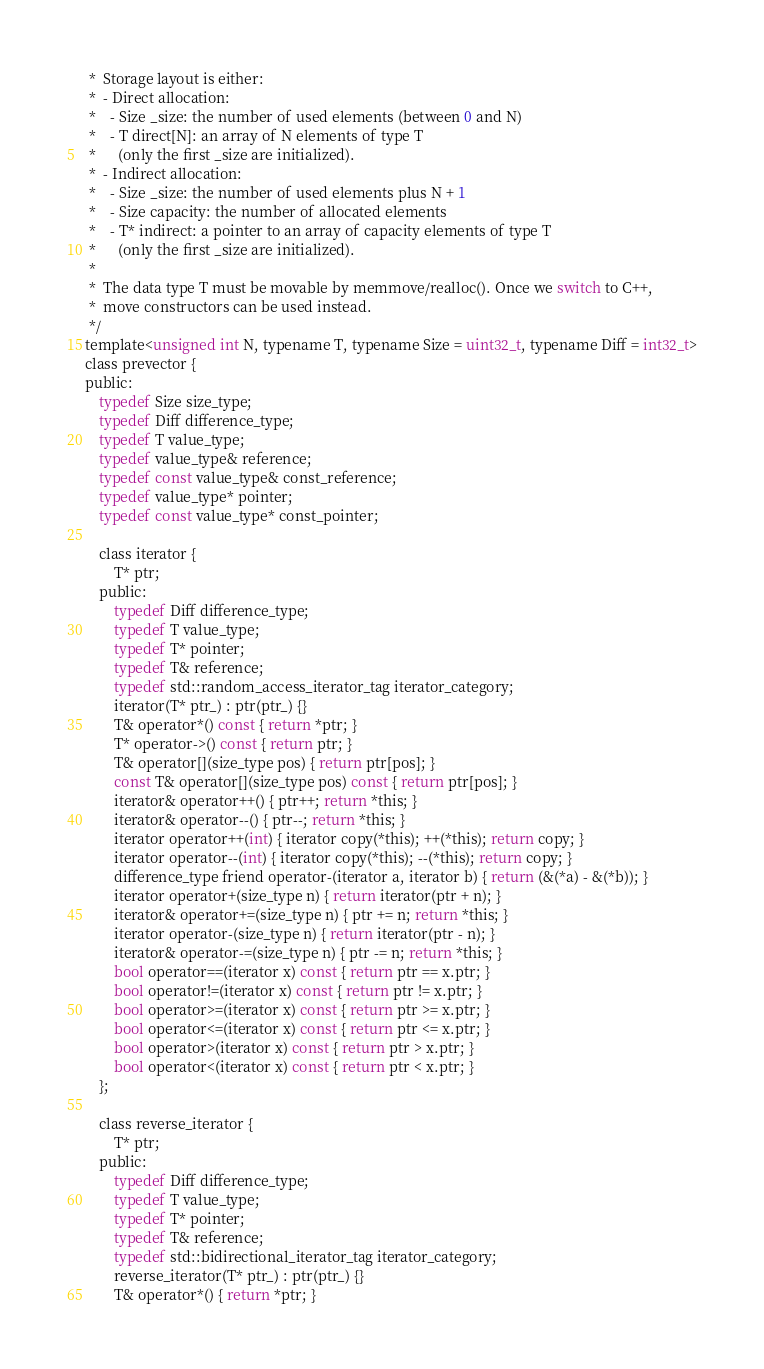Convert code to text. <code><loc_0><loc_0><loc_500><loc_500><_C_> *  Storage layout is either:
 *  - Direct allocation:
 *    - Size _size: the number of used elements (between 0 and N)
 *    - T direct[N]: an array of N elements of type T
 *      (only the first _size are initialized).
 *  - Indirect allocation:
 *    - Size _size: the number of used elements plus N + 1
 *    - Size capacity: the number of allocated elements
 *    - T* indirect: a pointer to an array of capacity elements of type T
 *      (only the first _size are initialized).
 *
 *  The data type T must be movable by memmove/realloc(). Once we switch to C++,
 *  move constructors can be used instead.
 */
template<unsigned int N, typename T, typename Size = uint32_t, typename Diff = int32_t>
class prevector {
public:
    typedef Size size_type;
    typedef Diff difference_type;
    typedef T value_type;
    typedef value_type& reference;
    typedef const value_type& const_reference;
    typedef value_type* pointer;
    typedef const value_type* const_pointer;

    class iterator {
        T* ptr;
    public:
        typedef Diff difference_type;
        typedef T value_type;
        typedef T* pointer;
        typedef T& reference;
        typedef std::random_access_iterator_tag iterator_category;
        iterator(T* ptr_) : ptr(ptr_) {}
        T& operator*() const { return *ptr; }
        T* operator->() const { return ptr; }
        T& operator[](size_type pos) { return ptr[pos]; }
        const T& operator[](size_type pos) const { return ptr[pos]; }
        iterator& operator++() { ptr++; return *this; }
        iterator& operator--() { ptr--; return *this; }
        iterator operator++(int) { iterator copy(*this); ++(*this); return copy; }
        iterator operator--(int) { iterator copy(*this); --(*this); return copy; }
        difference_type friend operator-(iterator a, iterator b) { return (&(*a) - &(*b)); }
        iterator operator+(size_type n) { return iterator(ptr + n); }
        iterator& operator+=(size_type n) { ptr += n; return *this; }
        iterator operator-(size_type n) { return iterator(ptr - n); }
        iterator& operator-=(size_type n) { ptr -= n; return *this; }
        bool operator==(iterator x) const { return ptr == x.ptr; }
        bool operator!=(iterator x) const { return ptr != x.ptr; }
        bool operator>=(iterator x) const { return ptr >= x.ptr; }
        bool operator<=(iterator x) const { return ptr <= x.ptr; }
        bool operator>(iterator x) const { return ptr > x.ptr; }
        bool operator<(iterator x) const { return ptr < x.ptr; }
    };

    class reverse_iterator {
        T* ptr;
    public:
        typedef Diff difference_type;
        typedef T value_type;
        typedef T* pointer;
        typedef T& reference;
        typedef std::bidirectional_iterator_tag iterator_category;
        reverse_iterator(T* ptr_) : ptr(ptr_) {}
        T& operator*() { return *ptr; }</code> 